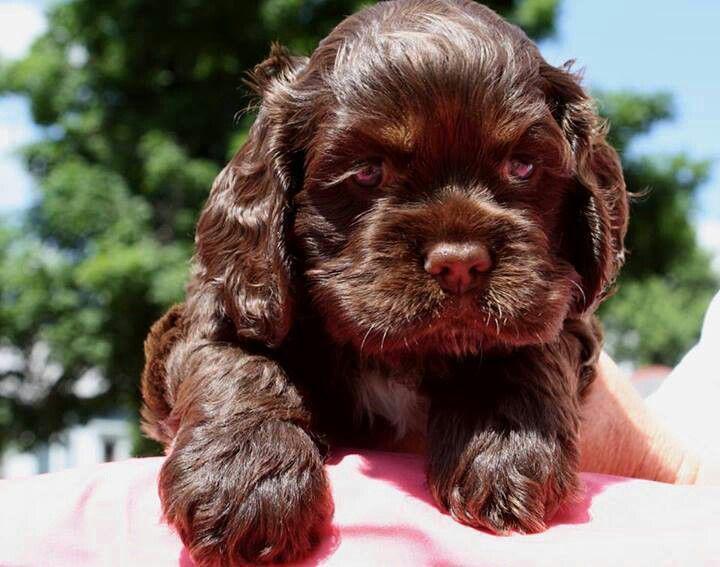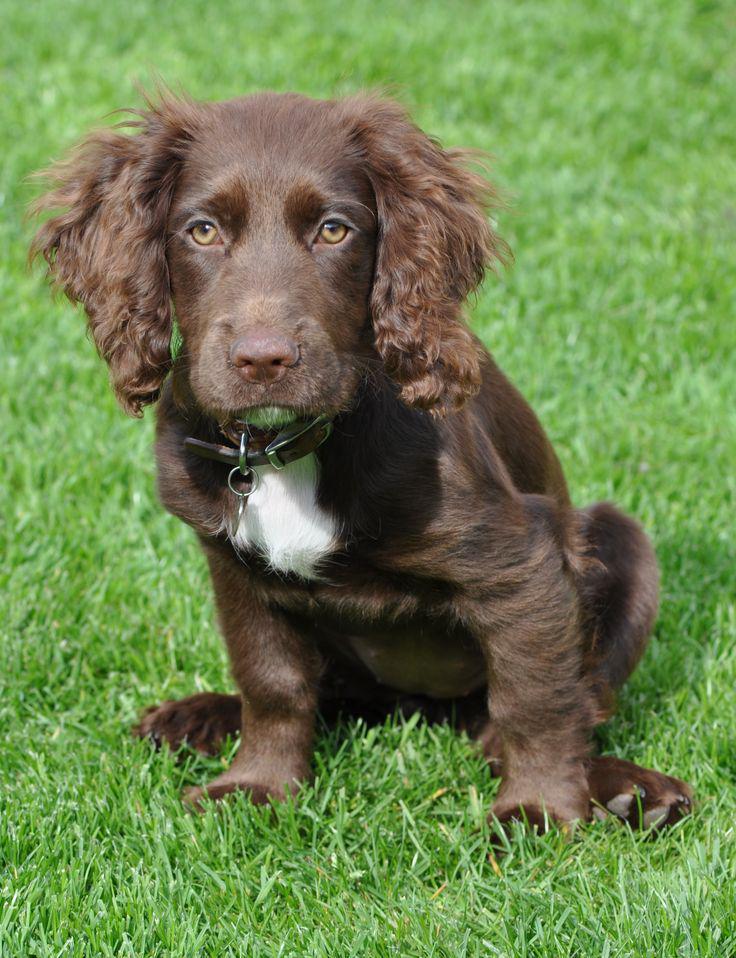The first image is the image on the left, the second image is the image on the right. Analyze the images presented: Is the assertion "Each image contains exactly one spaniel, and the dog on the left is younger than the one on the right, which wears a collar but no leash." valid? Answer yes or no. Yes. The first image is the image on the left, the second image is the image on the right. Assess this claim about the two images: "One dog is brown and white". Correct or not? Answer yes or no. Yes. 